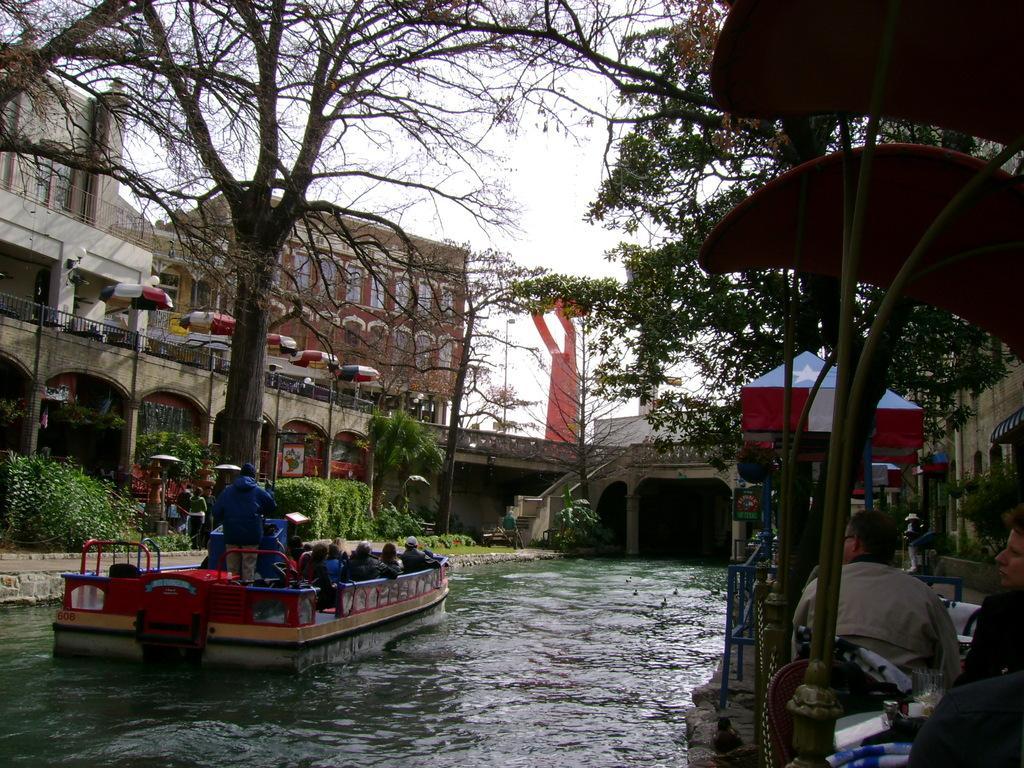Please provide a concise description of this image. In this image we can see we can see these people are sitting in the boat which is floating on the water. Here we can see a few people are sitting on the chairs near the table, we can see bridge, shrubs, trees, buildings and the sky in the background. 